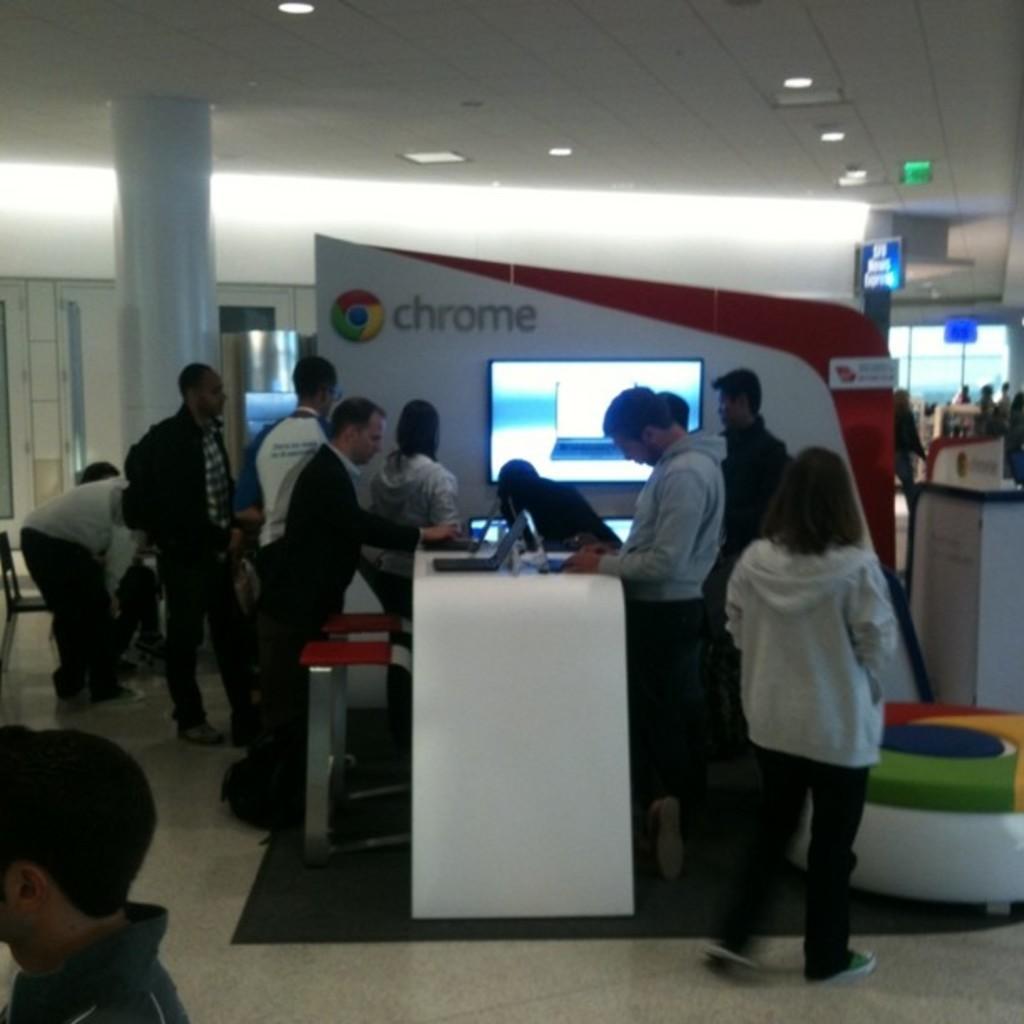Describe this image in one or two sentences. In this picture there are group of people standing and there are laptops and there are devices on the table. At the back there is a screen and there is text on the board and there is a woman walking. At the back there is a glass wall. At the top there are boards and lights. At the bottom there is a floor and mat. 